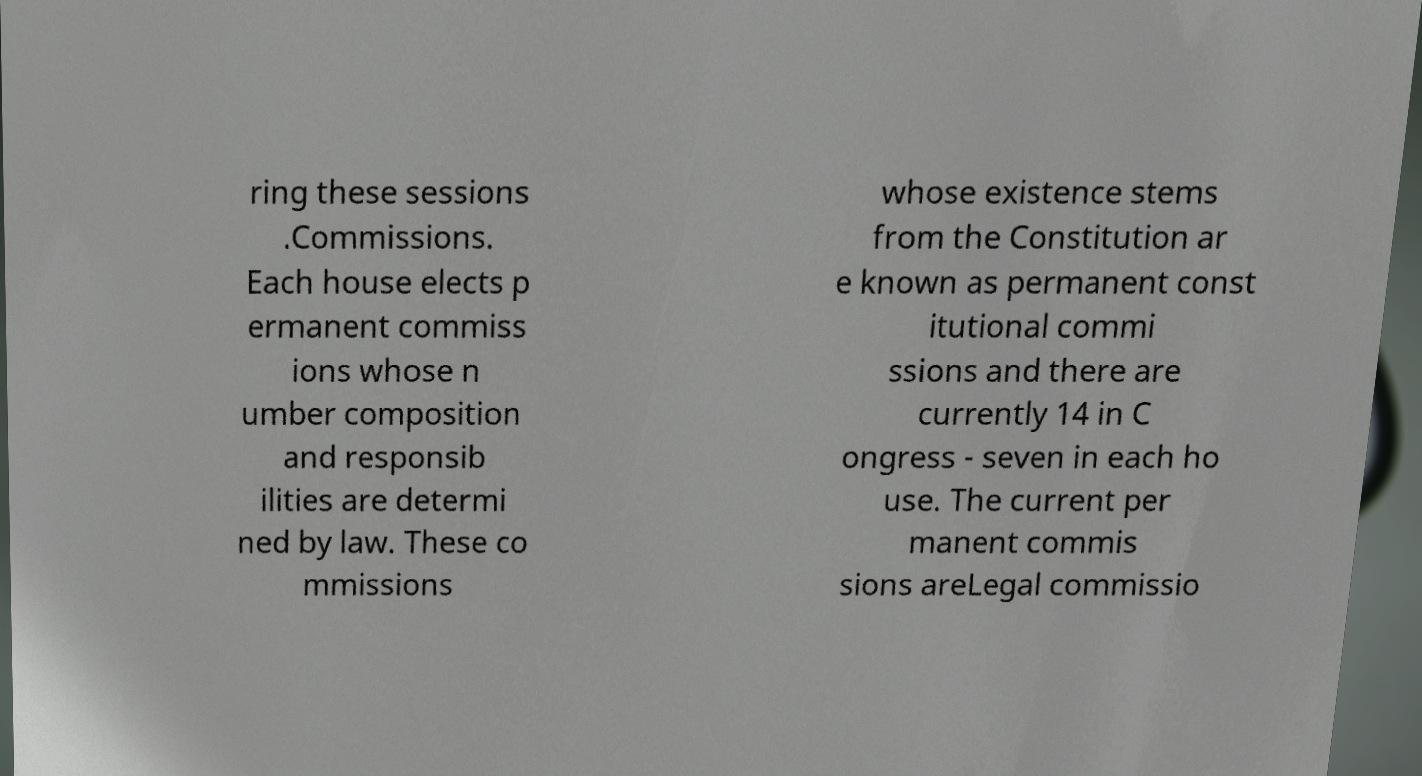Could you extract and type out the text from this image? ring these sessions .Commissions. Each house elects p ermanent commiss ions whose n umber composition and responsib ilities are determi ned by law. These co mmissions whose existence stems from the Constitution ar e known as permanent const itutional commi ssions and there are currently 14 in C ongress - seven in each ho use. The current per manent commis sions areLegal commissio 